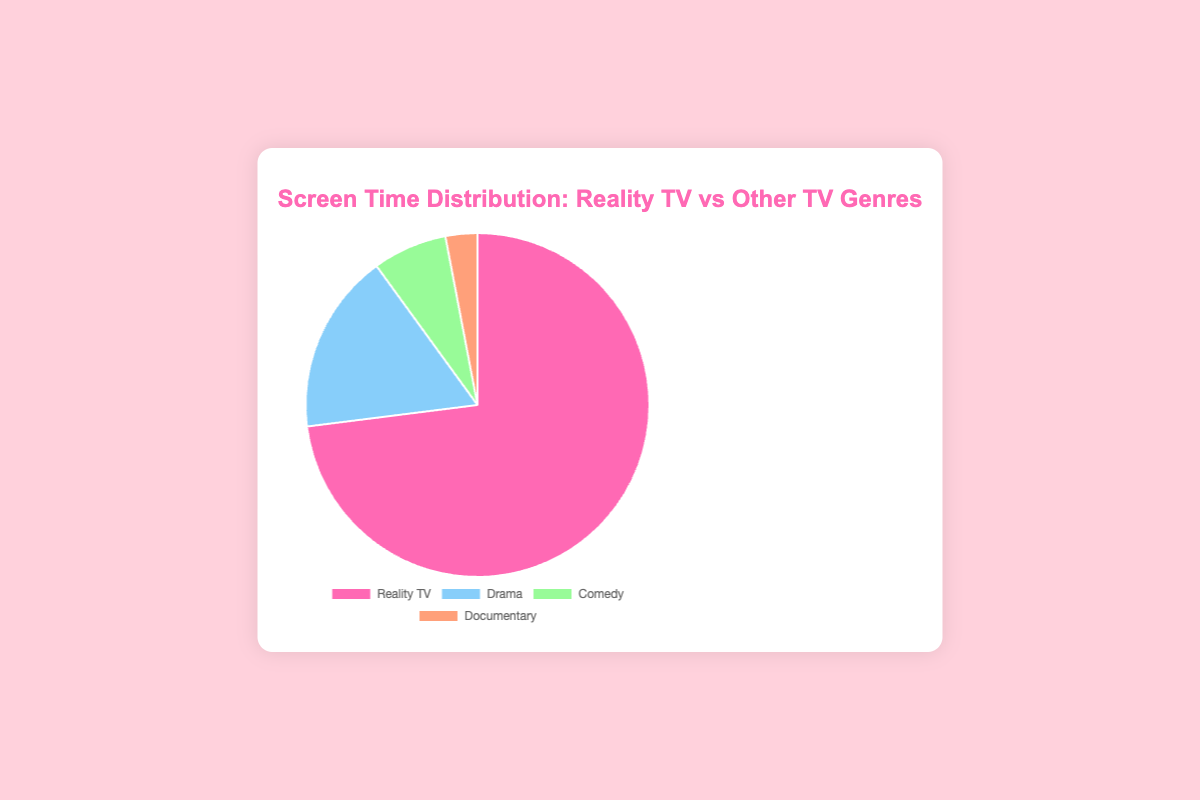What percentage of screen time is dedicated to Reality TV? By observing the pie chart, the section labeled "Reality TV" represents 73% of the total screen time.
Answer: 73% Which genre has the lowest percentage of screen time? The pie chart shows that "Documentary" has the smallest slice, indicating the smallest percentage, which is 3%.
Answer: Documentary How much more screen time does Reality TV have compared to Drama? Reality TV is 73% and Drama is 17%. The difference is calculated by subtracting 17 from 73, which is 73 - 17 = 56.
Answer: 56% What are the top two genres in terms of screen time? From the pie chart, "Reality TV" and "Drama" have the largest segments, with 73% and 17% respectively.
Answer: Reality TV, Drama What is the combined screen time percentage of Comedy and Documentary genres? Add the percentages of Comedy (7%) and Documentary (3%), which results in 7 + 3 = 10.
Answer: 10% Which genre has the largest segment in the pie chart and what color represents it? The largest segment is for Reality TV, which is represented by the color pink.
Answer: Reality TV, pink By how much does Reality TV’s screen time exceed the combined screen time of Drama and Comedy? The sum of Drama (17%) and Comedy (7%) is 17 + 7 = 24. The difference between Reality TV (73%) and this combined value is calculated by subtracting 24 from 73, which is 73 - 24 = 49.
Answer: 49% If the total screen time for all genres equals 100 hours, how many hours of screen time are dedicated to Reality TV? Reality TV represents 73% of the total screen time. To find the hours, calculate 73% of 100, which is 0.73 * 100 = 73.
Answer: 73 hours 